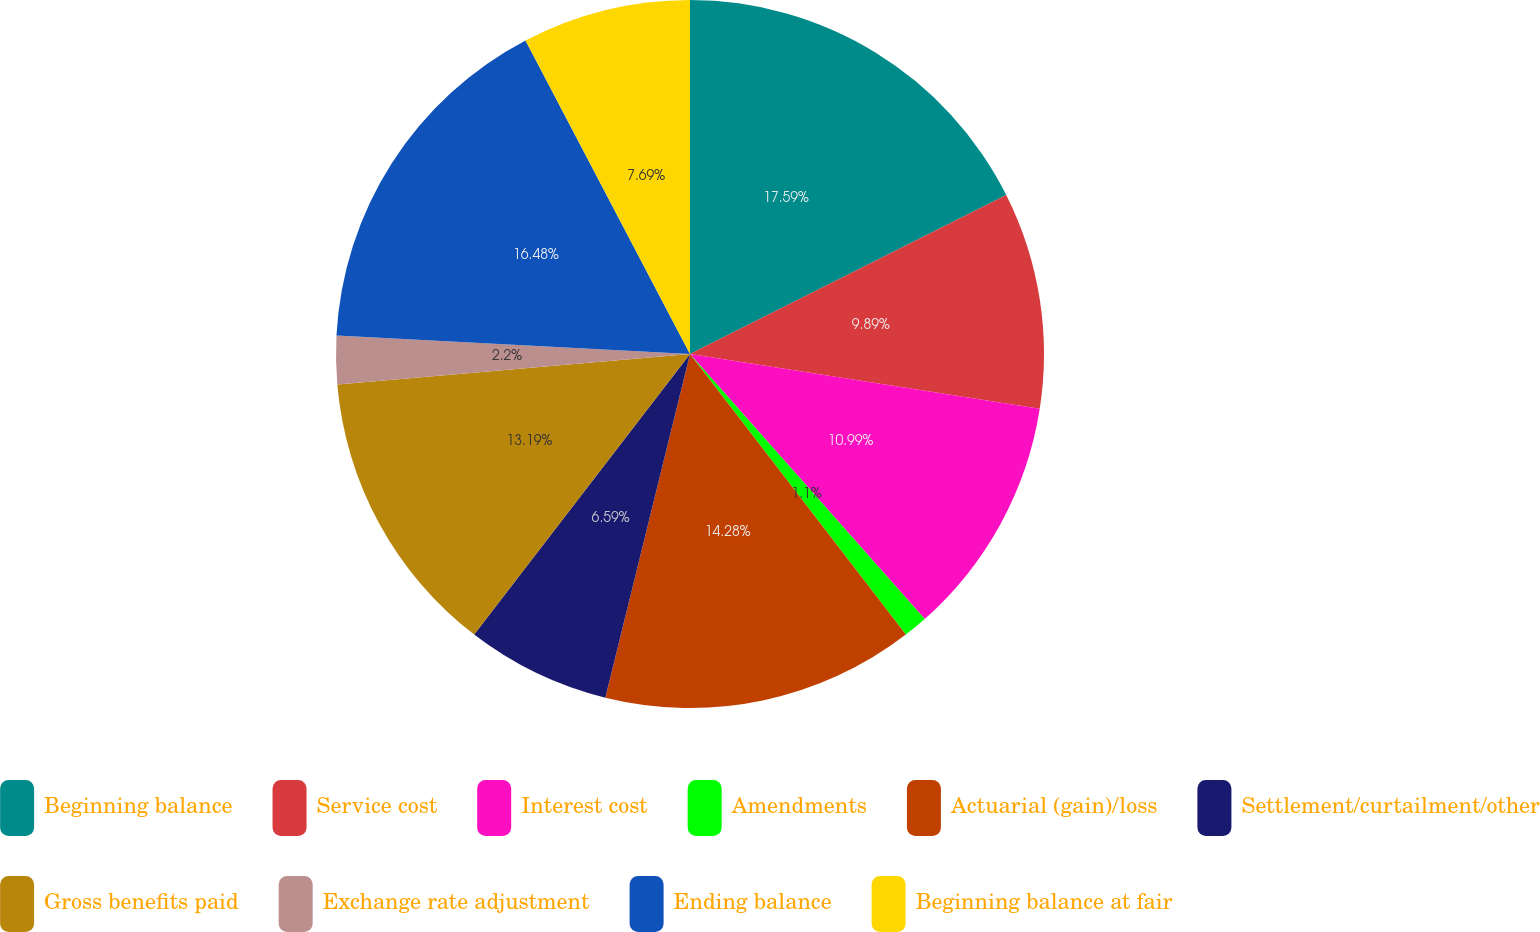Convert chart. <chart><loc_0><loc_0><loc_500><loc_500><pie_chart><fcel>Beginning balance<fcel>Service cost<fcel>Interest cost<fcel>Amendments<fcel>Actuarial (gain)/loss<fcel>Settlement/curtailment/other<fcel>Gross benefits paid<fcel>Exchange rate adjustment<fcel>Ending balance<fcel>Beginning balance at fair<nl><fcel>17.58%<fcel>9.89%<fcel>10.99%<fcel>1.1%<fcel>14.28%<fcel>6.59%<fcel>13.19%<fcel>2.2%<fcel>16.48%<fcel>7.69%<nl></chart> 